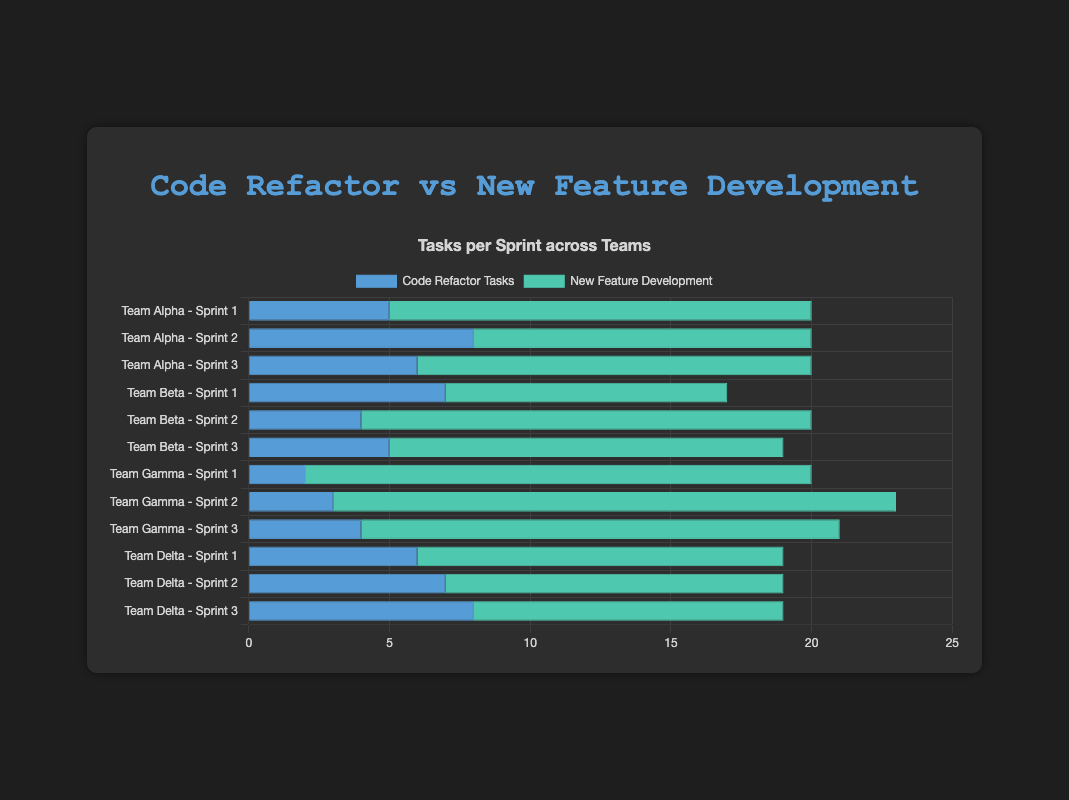What is the total number of code refactor tasks for Team Alpha across all sprints? To find the total number of code refactor tasks for Team Alpha, add the code refactor tasks from Sprint 1, Sprint 2, and Sprint 3: 5 + 8 + 6
Answer: 19 Which team performed the most new feature development tasks in Sprint 2? To determine which team performed the most new feature development tasks in Sprint 2, compare the values for Team Alpha (12), Team Beta (16), Team Gamma (20), and Team Delta (12). Team Gamma has the highest value.
Answer: Team Gamma Is the number of code refactor tasks for Team Beta in Sprint 1 greater than or equal to that in Sprint 2? For Sprint 1, Team Beta has 7 code refactor tasks, and for Sprint 2, they have 4 code refactor tasks. 7 is greater than 4
Answer: Yes What is the average number of new feature development tasks performed by Team Delta across all sprints? Sum the new feature development tasks for Team Delta across all sprints: 13 + 12 + 11 = 36. Divide by 3 (number of sprints): 36 / 3 = 12
Answer: 12 Which team has the smallest visual bar for code refactor tasks in Sprint 1? Look at the bars representing code refactor tasks in Sprint 1 for all teams. Team Gamma's bar (2) is the smallest.
Answer: Team Gamma Compare the total number of new feature development tasks by Team Alpha in Sprint 3 to Team Beta in Sprint 3. Are they equal? Team Alpha in Sprint 3 has 14 new feature development tasks, while Team Beta in Sprint 3 has 14 tasks as well. They are equal.
Answer: Yes What is the difference in the number of code refactor tasks between Team Delta in Sprint 2 and Team Alpha in Sprint 1? Subtract Team Alpha's code refactor tasks in Sprint 1 (5) from Team Delta's code refactor tasks in Sprint 2 (7): 7 - 5 = 2
Answer: 2 Which team has the highest total number of tasks (sum of code refactor and new feature development tasks) in Sprint 3? Add the code refactor and new feature development tasks for each team in Sprint 3: Team Alpha (6 + 14 = 20), Team Beta (5 + 14 = 19), Team Gamma (4 + 17 = 21), Team Delta (8 + 11 = 19). Team Gamma has 21.
Answer: Team Gamma How many more new feature development tasks did Team Gamma perform in Sprint 2 compared to Team Beta in Sprint 2? Subtract Team Beta's new feature development tasks in Sprint 2 (16) from Team Gamma's new feature development tasks in Sprint 2 (20): 20 - 16 = 4
Answer: 4 